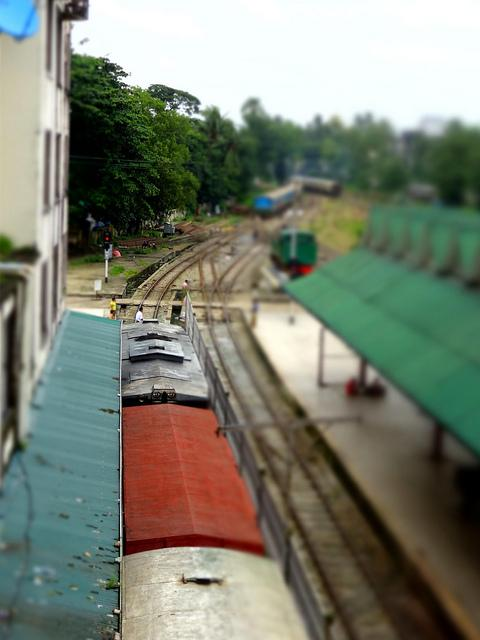What color is the train car in the center of the three cars? Please explain your reasoning. red. The other ones are red and black 